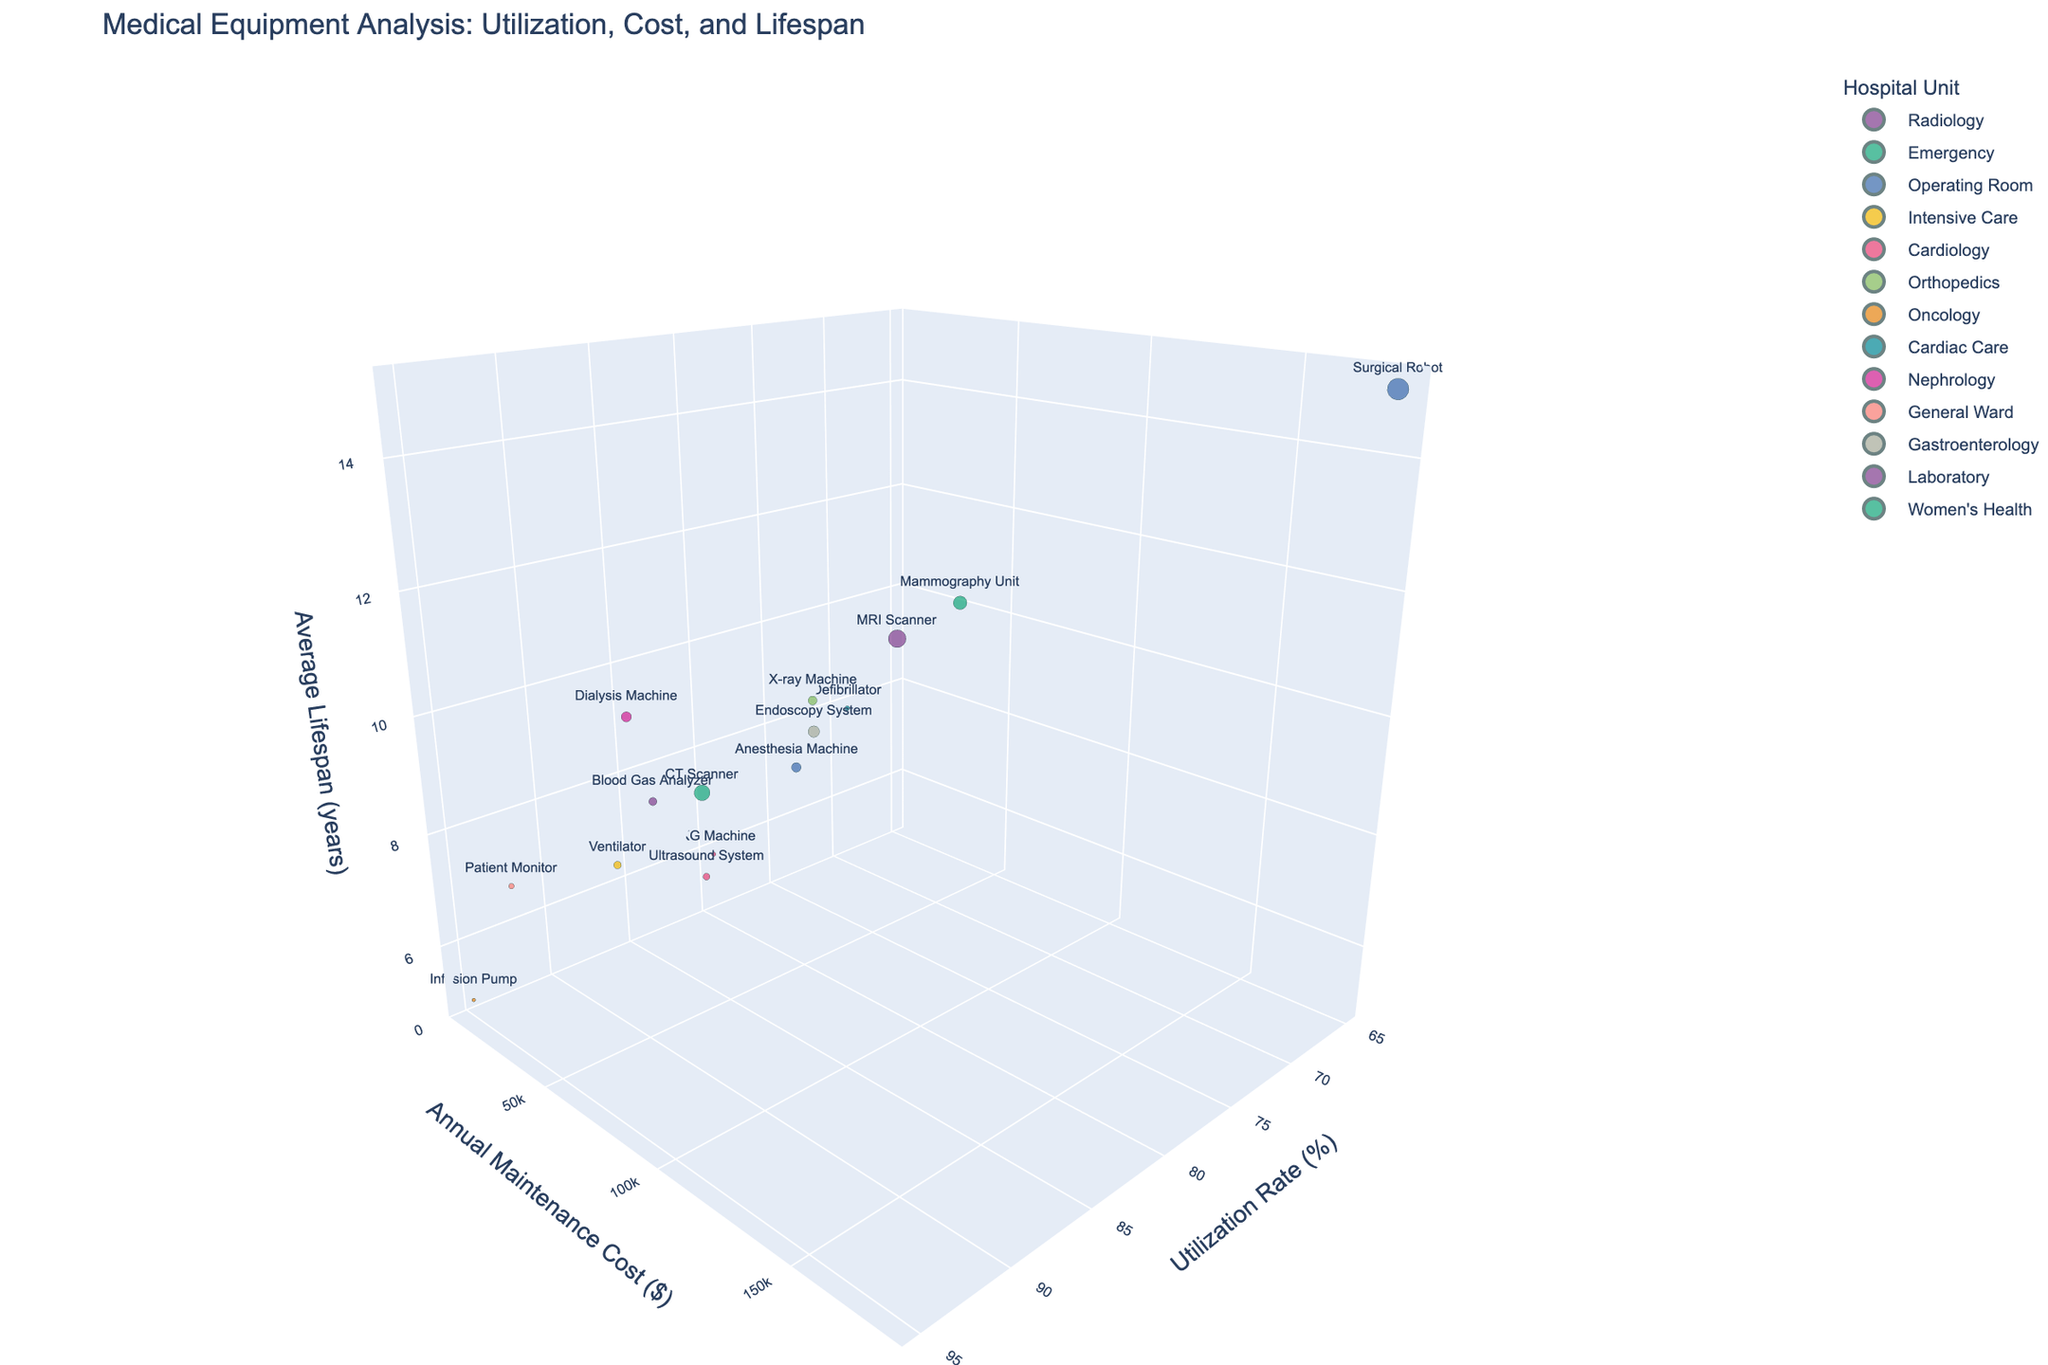What's the title of the graph? The title of the graph is usually prominently displayed at the top. In this case, the title shown is "Medical Equipment Analysis: Utilization, Cost, and Lifespan".
Answer: Medical Equipment Analysis: Utilization, Cost, and Lifespan How many pieces of equipment are represented in the Cardiology unit? By examining the graph, we can see that each unit is color-coded, and pieces of equipment are labeled. Cardiology equipment includes the Ultrasound System and the EKG Machine.
Answer: 2 Which equipment has the highest utilization rate in the graph? The utilization rate is plotted on the x-axis. By looking at the farthest point to the right on this axis, we can identify the Infusion Pump, which has a utilization rate of 95%.
Answer: Infusion Pump Which unit has the highest annual maintenance cost represented by the largest bubble? The size of the bubbles indicates the annual maintenance cost. By finding the largest bubble, it points to the Surgical Robot in the Operating Room unit.
Answer: Operating Room (Surgical Robot) What is the average lifespan of the MRI Scanner? The average lifespan is shown on the z-axis. By finding the position of the MRI Scanner, we see it is at the point with a lifespan of 12 years.
Answer: 12 years Which equipment in the Operating Room unit has a longer lifespan, the Anesthesia Machine or the Surgical Robot? By comparing the z-axis positions of the Anesthesia Machine and the Surgical Robot in the Operating Room, the bubble for the Surgical Robot is higher up, indicating a longer lifespan.
Answer: Surgical Robot What is the combined annual maintenance cost of the Dialysis Machine and Mammography Unit? Find the y-coordinate values for the Dialysis Machine (40000) and Mammography Unit (70000), then sum them: 40000 + 70000 = 110000.
Answer: 110000 Which equipment has a utilization rate closest to 90% and what unit is it in? By examining the equipment positions near the 90% mark on the x-axis, we see the CT Scanner in the Emergency unit has a 92% utilization rate.
Answer: CT Scanner, Emergency Which piece of equipment in the Intensive Care unit has the highest average lifespan? Look at the equipment in the Intensive Care unit and compare their z-axis positions. The Ventilator has a higher position (7 years) compared to the other Intensive Care units.
Answer: Ventilator How does the lifespan of the Blood Gas Analyzer compare to that of the Endoscopy System? Compare the z-axis values of the Blood Gas Analyzer (8 years) and the Endoscopy System (9 years) to see that the Endoscopy System has a slightly longer lifespan.
Answer: Endoscopy System has a longer lifespan 